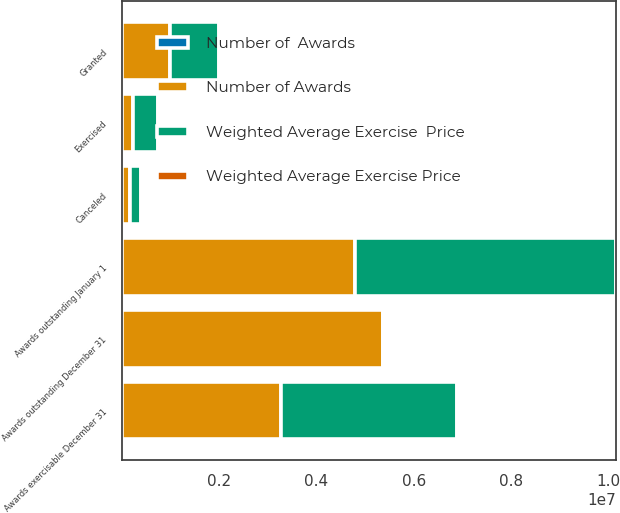Convert chart. <chart><loc_0><loc_0><loc_500><loc_500><stacked_bar_chart><ecel><fcel>Awards outstanding January 1<fcel>Granted<fcel>Exercised<fcel>Canceled<fcel>Awards outstanding December 31<fcel>Awards exercisable December 31<nl><fcel>Weighted Average Exercise  Price<fcel>5.3754e+06<fcel>1.0175e+06<fcel>506154<fcel>228750<fcel>43.63<fcel>3.63507e+06<nl><fcel>Weighted Average Exercise Price<fcel>30.84<fcel>27.9<fcel>16.55<fcel>39.34<fcel>31.24<fcel>28.44<nl><fcel>Number of Awards<fcel>4.78704e+06<fcel>980000<fcel>226695<fcel>164946<fcel>5.3754e+06<fcel>3.26298e+06<nl><fcel>Number of  Awards<fcel>28.09<fcel>43.63<fcel>19.96<fcel>41.96<fcel>30.84<fcel>24.1<nl></chart> 